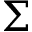<formula> <loc_0><loc_0><loc_500><loc_500>\Sigma</formula> 